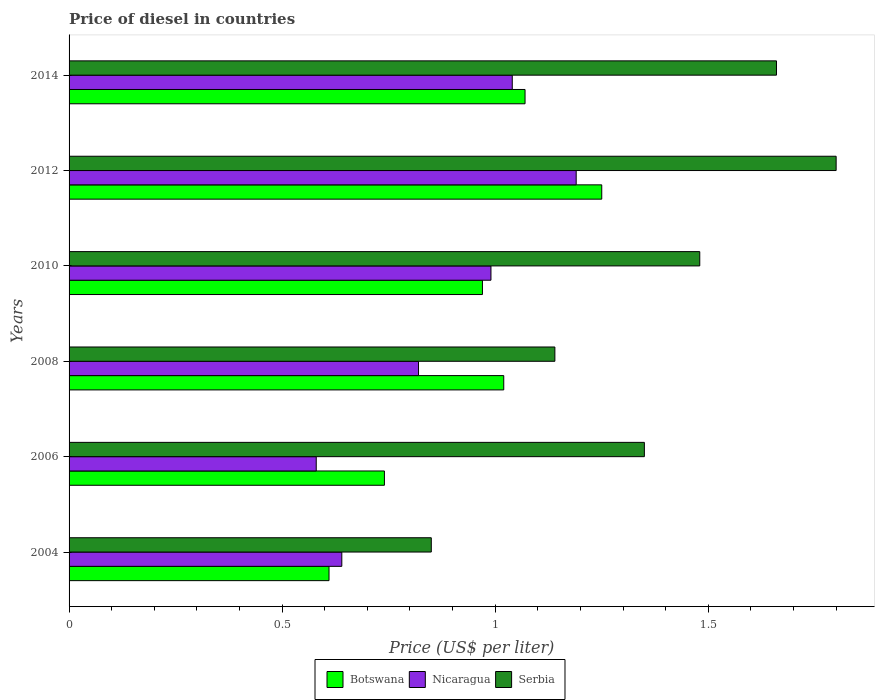How many different coloured bars are there?
Offer a very short reply. 3. How many groups of bars are there?
Offer a terse response. 6. Are the number of bars on each tick of the Y-axis equal?
Keep it short and to the point. Yes. In how many cases, is the number of bars for a given year not equal to the number of legend labels?
Keep it short and to the point. 0. Across all years, what is the maximum price of diesel in Botswana?
Your answer should be compact. 1.25. Across all years, what is the minimum price of diesel in Serbia?
Your response must be concise. 0.85. In which year was the price of diesel in Serbia minimum?
Offer a terse response. 2004. What is the total price of diesel in Serbia in the graph?
Your answer should be compact. 8.28. What is the difference between the price of diesel in Botswana in 2004 and that in 2010?
Your answer should be compact. -0.36. What is the difference between the price of diesel in Botswana in 2004 and the price of diesel in Nicaragua in 2010?
Offer a terse response. -0.38. What is the average price of diesel in Nicaragua per year?
Offer a terse response. 0.88. In the year 2006, what is the difference between the price of diesel in Serbia and price of diesel in Nicaragua?
Make the answer very short. 0.77. In how many years, is the price of diesel in Serbia greater than 0.6 US$?
Your answer should be very brief. 6. What is the ratio of the price of diesel in Nicaragua in 2004 to that in 2010?
Offer a very short reply. 0.65. Is the price of diesel in Nicaragua in 2004 less than that in 2012?
Offer a very short reply. Yes. What is the difference between the highest and the second highest price of diesel in Botswana?
Keep it short and to the point. 0.18. What is the difference between the highest and the lowest price of diesel in Nicaragua?
Keep it short and to the point. 0.61. Is the sum of the price of diesel in Serbia in 2004 and 2008 greater than the maximum price of diesel in Nicaragua across all years?
Offer a very short reply. Yes. What does the 2nd bar from the top in 2012 represents?
Provide a succinct answer. Nicaragua. What does the 1st bar from the bottom in 2012 represents?
Give a very brief answer. Botswana. How many years are there in the graph?
Your response must be concise. 6. Are the values on the major ticks of X-axis written in scientific E-notation?
Your answer should be very brief. No. Does the graph contain any zero values?
Provide a short and direct response. No. Does the graph contain grids?
Offer a terse response. No. What is the title of the graph?
Ensure brevity in your answer.  Price of diesel in countries. Does "Brunei Darussalam" appear as one of the legend labels in the graph?
Offer a very short reply. No. What is the label or title of the X-axis?
Your response must be concise. Price (US$ per liter). What is the Price (US$ per liter) in Botswana in 2004?
Offer a terse response. 0.61. What is the Price (US$ per liter) in Nicaragua in 2004?
Your answer should be very brief. 0.64. What is the Price (US$ per liter) in Serbia in 2004?
Make the answer very short. 0.85. What is the Price (US$ per liter) of Botswana in 2006?
Your answer should be very brief. 0.74. What is the Price (US$ per liter) in Nicaragua in 2006?
Provide a short and direct response. 0.58. What is the Price (US$ per liter) in Serbia in 2006?
Make the answer very short. 1.35. What is the Price (US$ per liter) in Botswana in 2008?
Make the answer very short. 1.02. What is the Price (US$ per liter) in Nicaragua in 2008?
Make the answer very short. 0.82. What is the Price (US$ per liter) in Serbia in 2008?
Offer a very short reply. 1.14. What is the Price (US$ per liter) in Nicaragua in 2010?
Your answer should be very brief. 0.99. What is the Price (US$ per liter) in Serbia in 2010?
Give a very brief answer. 1.48. What is the Price (US$ per liter) of Botswana in 2012?
Your response must be concise. 1.25. What is the Price (US$ per liter) in Nicaragua in 2012?
Keep it short and to the point. 1.19. What is the Price (US$ per liter) of Botswana in 2014?
Provide a short and direct response. 1.07. What is the Price (US$ per liter) in Serbia in 2014?
Offer a very short reply. 1.66. Across all years, what is the maximum Price (US$ per liter) in Nicaragua?
Your response must be concise. 1.19. Across all years, what is the maximum Price (US$ per liter) of Serbia?
Make the answer very short. 1.8. Across all years, what is the minimum Price (US$ per liter) in Botswana?
Your answer should be very brief. 0.61. Across all years, what is the minimum Price (US$ per liter) in Nicaragua?
Keep it short and to the point. 0.58. Across all years, what is the minimum Price (US$ per liter) in Serbia?
Offer a very short reply. 0.85. What is the total Price (US$ per liter) of Botswana in the graph?
Keep it short and to the point. 5.66. What is the total Price (US$ per liter) in Nicaragua in the graph?
Ensure brevity in your answer.  5.26. What is the total Price (US$ per liter) in Serbia in the graph?
Your response must be concise. 8.28. What is the difference between the Price (US$ per liter) of Botswana in 2004 and that in 2006?
Make the answer very short. -0.13. What is the difference between the Price (US$ per liter) in Nicaragua in 2004 and that in 2006?
Provide a succinct answer. 0.06. What is the difference between the Price (US$ per liter) of Serbia in 2004 and that in 2006?
Provide a short and direct response. -0.5. What is the difference between the Price (US$ per liter) of Botswana in 2004 and that in 2008?
Offer a terse response. -0.41. What is the difference between the Price (US$ per liter) of Nicaragua in 2004 and that in 2008?
Provide a short and direct response. -0.18. What is the difference between the Price (US$ per liter) in Serbia in 2004 and that in 2008?
Offer a terse response. -0.29. What is the difference between the Price (US$ per liter) of Botswana in 2004 and that in 2010?
Your answer should be compact. -0.36. What is the difference between the Price (US$ per liter) in Nicaragua in 2004 and that in 2010?
Your response must be concise. -0.35. What is the difference between the Price (US$ per liter) in Serbia in 2004 and that in 2010?
Provide a short and direct response. -0.63. What is the difference between the Price (US$ per liter) in Botswana in 2004 and that in 2012?
Ensure brevity in your answer.  -0.64. What is the difference between the Price (US$ per liter) in Nicaragua in 2004 and that in 2012?
Provide a short and direct response. -0.55. What is the difference between the Price (US$ per liter) of Serbia in 2004 and that in 2012?
Provide a succinct answer. -0.95. What is the difference between the Price (US$ per liter) in Botswana in 2004 and that in 2014?
Give a very brief answer. -0.46. What is the difference between the Price (US$ per liter) of Nicaragua in 2004 and that in 2014?
Your response must be concise. -0.4. What is the difference between the Price (US$ per liter) of Serbia in 2004 and that in 2014?
Your response must be concise. -0.81. What is the difference between the Price (US$ per liter) of Botswana in 2006 and that in 2008?
Give a very brief answer. -0.28. What is the difference between the Price (US$ per liter) of Nicaragua in 2006 and that in 2008?
Make the answer very short. -0.24. What is the difference between the Price (US$ per liter) of Serbia in 2006 and that in 2008?
Offer a terse response. 0.21. What is the difference between the Price (US$ per liter) in Botswana in 2006 and that in 2010?
Ensure brevity in your answer.  -0.23. What is the difference between the Price (US$ per liter) of Nicaragua in 2006 and that in 2010?
Ensure brevity in your answer.  -0.41. What is the difference between the Price (US$ per liter) of Serbia in 2006 and that in 2010?
Provide a short and direct response. -0.13. What is the difference between the Price (US$ per liter) of Botswana in 2006 and that in 2012?
Ensure brevity in your answer.  -0.51. What is the difference between the Price (US$ per liter) of Nicaragua in 2006 and that in 2012?
Offer a very short reply. -0.61. What is the difference between the Price (US$ per liter) of Serbia in 2006 and that in 2012?
Make the answer very short. -0.45. What is the difference between the Price (US$ per liter) in Botswana in 2006 and that in 2014?
Offer a very short reply. -0.33. What is the difference between the Price (US$ per liter) of Nicaragua in 2006 and that in 2014?
Your response must be concise. -0.46. What is the difference between the Price (US$ per liter) of Serbia in 2006 and that in 2014?
Keep it short and to the point. -0.31. What is the difference between the Price (US$ per liter) of Botswana in 2008 and that in 2010?
Give a very brief answer. 0.05. What is the difference between the Price (US$ per liter) of Nicaragua in 2008 and that in 2010?
Your response must be concise. -0.17. What is the difference between the Price (US$ per liter) of Serbia in 2008 and that in 2010?
Ensure brevity in your answer.  -0.34. What is the difference between the Price (US$ per liter) of Botswana in 2008 and that in 2012?
Your answer should be very brief. -0.23. What is the difference between the Price (US$ per liter) in Nicaragua in 2008 and that in 2012?
Provide a succinct answer. -0.37. What is the difference between the Price (US$ per liter) of Serbia in 2008 and that in 2012?
Your response must be concise. -0.66. What is the difference between the Price (US$ per liter) in Nicaragua in 2008 and that in 2014?
Offer a very short reply. -0.22. What is the difference between the Price (US$ per liter) in Serbia in 2008 and that in 2014?
Make the answer very short. -0.52. What is the difference between the Price (US$ per liter) of Botswana in 2010 and that in 2012?
Make the answer very short. -0.28. What is the difference between the Price (US$ per liter) of Nicaragua in 2010 and that in 2012?
Ensure brevity in your answer.  -0.2. What is the difference between the Price (US$ per liter) of Serbia in 2010 and that in 2012?
Your response must be concise. -0.32. What is the difference between the Price (US$ per liter) in Serbia in 2010 and that in 2014?
Provide a succinct answer. -0.18. What is the difference between the Price (US$ per liter) in Botswana in 2012 and that in 2014?
Provide a short and direct response. 0.18. What is the difference between the Price (US$ per liter) in Serbia in 2012 and that in 2014?
Provide a succinct answer. 0.14. What is the difference between the Price (US$ per liter) in Botswana in 2004 and the Price (US$ per liter) in Nicaragua in 2006?
Keep it short and to the point. 0.03. What is the difference between the Price (US$ per liter) of Botswana in 2004 and the Price (US$ per liter) of Serbia in 2006?
Give a very brief answer. -0.74. What is the difference between the Price (US$ per liter) in Nicaragua in 2004 and the Price (US$ per liter) in Serbia in 2006?
Your answer should be compact. -0.71. What is the difference between the Price (US$ per liter) of Botswana in 2004 and the Price (US$ per liter) of Nicaragua in 2008?
Provide a short and direct response. -0.21. What is the difference between the Price (US$ per liter) in Botswana in 2004 and the Price (US$ per liter) in Serbia in 2008?
Offer a very short reply. -0.53. What is the difference between the Price (US$ per liter) of Nicaragua in 2004 and the Price (US$ per liter) of Serbia in 2008?
Your answer should be very brief. -0.5. What is the difference between the Price (US$ per liter) in Botswana in 2004 and the Price (US$ per liter) in Nicaragua in 2010?
Ensure brevity in your answer.  -0.38. What is the difference between the Price (US$ per liter) of Botswana in 2004 and the Price (US$ per liter) of Serbia in 2010?
Your answer should be compact. -0.87. What is the difference between the Price (US$ per liter) of Nicaragua in 2004 and the Price (US$ per liter) of Serbia in 2010?
Provide a short and direct response. -0.84. What is the difference between the Price (US$ per liter) in Botswana in 2004 and the Price (US$ per liter) in Nicaragua in 2012?
Your answer should be compact. -0.58. What is the difference between the Price (US$ per liter) in Botswana in 2004 and the Price (US$ per liter) in Serbia in 2012?
Provide a succinct answer. -1.19. What is the difference between the Price (US$ per liter) in Nicaragua in 2004 and the Price (US$ per liter) in Serbia in 2012?
Offer a terse response. -1.16. What is the difference between the Price (US$ per liter) in Botswana in 2004 and the Price (US$ per liter) in Nicaragua in 2014?
Offer a terse response. -0.43. What is the difference between the Price (US$ per liter) of Botswana in 2004 and the Price (US$ per liter) of Serbia in 2014?
Your answer should be compact. -1.05. What is the difference between the Price (US$ per liter) in Nicaragua in 2004 and the Price (US$ per liter) in Serbia in 2014?
Your answer should be very brief. -1.02. What is the difference between the Price (US$ per liter) of Botswana in 2006 and the Price (US$ per liter) of Nicaragua in 2008?
Offer a very short reply. -0.08. What is the difference between the Price (US$ per liter) in Botswana in 2006 and the Price (US$ per liter) in Serbia in 2008?
Your answer should be very brief. -0.4. What is the difference between the Price (US$ per liter) of Nicaragua in 2006 and the Price (US$ per liter) of Serbia in 2008?
Provide a short and direct response. -0.56. What is the difference between the Price (US$ per liter) in Botswana in 2006 and the Price (US$ per liter) in Nicaragua in 2010?
Your answer should be very brief. -0.25. What is the difference between the Price (US$ per liter) of Botswana in 2006 and the Price (US$ per liter) of Serbia in 2010?
Offer a very short reply. -0.74. What is the difference between the Price (US$ per liter) in Botswana in 2006 and the Price (US$ per liter) in Nicaragua in 2012?
Your response must be concise. -0.45. What is the difference between the Price (US$ per liter) of Botswana in 2006 and the Price (US$ per liter) of Serbia in 2012?
Your response must be concise. -1.06. What is the difference between the Price (US$ per liter) of Nicaragua in 2006 and the Price (US$ per liter) of Serbia in 2012?
Your response must be concise. -1.22. What is the difference between the Price (US$ per liter) of Botswana in 2006 and the Price (US$ per liter) of Nicaragua in 2014?
Offer a terse response. -0.3. What is the difference between the Price (US$ per liter) of Botswana in 2006 and the Price (US$ per liter) of Serbia in 2014?
Ensure brevity in your answer.  -0.92. What is the difference between the Price (US$ per liter) in Nicaragua in 2006 and the Price (US$ per liter) in Serbia in 2014?
Provide a succinct answer. -1.08. What is the difference between the Price (US$ per liter) in Botswana in 2008 and the Price (US$ per liter) in Serbia in 2010?
Make the answer very short. -0.46. What is the difference between the Price (US$ per liter) in Nicaragua in 2008 and the Price (US$ per liter) in Serbia in 2010?
Your response must be concise. -0.66. What is the difference between the Price (US$ per liter) in Botswana in 2008 and the Price (US$ per liter) in Nicaragua in 2012?
Your answer should be very brief. -0.17. What is the difference between the Price (US$ per liter) of Botswana in 2008 and the Price (US$ per liter) of Serbia in 2012?
Provide a succinct answer. -0.78. What is the difference between the Price (US$ per liter) of Nicaragua in 2008 and the Price (US$ per liter) of Serbia in 2012?
Your response must be concise. -0.98. What is the difference between the Price (US$ per liter) of Botswana in 2008 and the Price (US$ per liter) of Nicaragua in 2014?
Keep it short and to the point. -0.02. What is the difference between the Price (US$ per liter) in Botswana in 2008 and the Price (US$ per liter) in Serbia in 2014?
Keep it short and to the point. -0.64. What is the difference between the Price (US$ per liter) in Nicaragua in 2008 and the Price (US$ per liter) in Serbia in 2014?
Offer a very short reply. -0.84. What is the difference between the Price (US$ per liter) of Botswana in 2010 and the Price (US$ per liter) of Nicaragua in 2012?
Offer a very short reply. -0.22. What is the difference between the Price (US$ per liter) of Botswana in 2010 and the Price (US$ per liter) of Serbia in 2012?
Ensure brevity in your answer.  -0.83. What is the difference between the Price (US$ per liter) of Nicaragua in 2010 and the Price (US$ per liter) of Serbia in 2012?
Keep it short and to the point. -0.81. What is the difference between the Price (US$ per liter) of Botswana in 2010 and the Price (US$ per liter) of Nicaragua in 2014?
Make the answer very short. -0.07. What is the difference between the Price (US$ per liter) in Botswana in 2010 and the Price (US$ per liter) in Serbia in 2014?
Provide a short and direct response. -0.69. What is the difference between the Price (US$ per liter) in Nicaragua in 2010 and the Price (US$ per liter) in Serbia in 2014?
Offer a very short reply. -0.67. What is the difference between the Price (US$ per liter) of Botswana in 2012 and the Price (US$ per liter) of Nicaragua in 2014?
Make the answer very short. 0.21. What is the difference between the Price (US$ per liter) in Botswana in 2012 and the Price (US$ per liter) in Serbia in 2014?
Make the answer very short. -0.41. What is the difference between the Price (US$ per liter) of Nicaragua in 2012 and the Price (US$ per liter) of Serbia in 2014?
Provide a succinct answer. -0.47. What is the average Price (US$ per liter) of Botswana per year?
Your answer should be very brief. 0.94. What is the average Price (US$ per liter) of Nicaragua per year?
Keep it short and to the point. 0.88. What is the average Price (US$ per liter) in Serbia per year?
Make the answer very short. 1.38. In the year 2004, what is the difference between the Price (US$ per liter) of Botswana and Price (US$ per liter) of Nicaragua?
Your answer should be very brief. -0.03. In the year 2004, what is the difference between the Price (US$ per liter) of Botswana and Price (US$ per liter) of Serbia?
Give a very brief answer. -0.24. In the year 2004, what is the difference between the Price (US$ per liter) in Nicaragua and Price (US$ per liter) in Serbia?
Offer a very short reply. -0.21. In the year 2006, what is the difference between the Price (US$ per liter) in Botswana and Price (US$ per liter) in Nicaragua?
Provide a short and direct response. 0.16. In the year 2006, what is the difference between the Price (US$ per liter) of Botswana and Price (US$ per liter) of Serbia?
Provide a short and direct response. -0.61. In the year 2006, what is the difference between the Price (US$ per liter) in Nicaragua and Price (US$ per liter) in Serbia?
Offer a very short reply. -0.77. In the year 2008, what is the difference between the Price (US$ per liter) in Botswana and Price (US$ per liter) in Nicaragua?
Your response must be concise. 0.2. In the year 2008, what is the difference between the Price (US$ per liter) of Botswana and Price (US$ per liter) of Serbia?
Ensure brevity in your answer.  -0.12. In the year 2008, what is the difference between the Price (US$ per liter) of Nicaragua and Price (US$ per liter) of Serbia?
Offer a terse response. -0.32. In the year 2010, what is the difference between the Price (US$ per liter) in Botswana and Price (US$ per liter) in Nicaragua?
Ensure brevity in your answer.  -0.02. In the year 2010, what is the difference between the Price (US$ per liter) of Botswana and Price (US$ per liter) of Serbia?
Give a very brief answer. -0.51. In the year 2010, what is the difference between the Price (US$ per liter) in Nicaragua and Price (US$ per liter) in Serbia?
Provide a short and direct response. -0.49. In the year 2012, what is the difference between the Price (US$ per liter) in Botswana and Price (US$ per liter) in Serbia?
Offer a terse response. -0.55. In the year 2012, what is the difference between the Price (US$ per liter) of Nicaragua and Price (US$ per liter) of Serbia?
Offer a terse response. -0.61. In the year 2014, what is the difference between the Price (US$ per liter) of Botswana and Price (US$ per liter) of Serbia?
Keep it short and to the point. -0.59. In the year 2014, what is the difference between the Price (US$ per liter) of Nicaragua and Price (US$ per liter) of Serbia?
Offer a very short reply. -0.62. What is the ratio of the Price (US$ per liter) of Botswana in 2004 to that in 2006?
Make the answer very short. 0.82. What is the ratio of the Price (US$ per liter) of Nicaragua in 2004 to that in 2006?
Your answer should be very brief. 1.1. What is the ratio of the Price (US$ per liter) of Serbia in 2004 to that in 2006?
Provide a succinct answer. 0.63. What is the ratio of the Price (US$ per liter) of Botswana in 2004 to that in 2008?
Ensure brevity in your answer.  0.6. What is the ratio of the Price (US$ per liter) of Nicaragua in 2004 to that in 2008?
Provide a succinct answer. 0.78. What is the ratio of the Price (US$ per liter) in Serbia in 2004 to that in 2008?
Offer a terse response. 0.75. What is the ratio of the Price (US$ per liter) of Botswana in 2004 to that in 2010?
Your answer should be compact. 0.63. What is the ratio of the Price (US$ per liter) of Nicaragua in 2004 to that in 2010?
Make the answer very short. 0.65. What is the ratio of the Price (US$ per liter) in Serbia in 2004 to that in 2010?
Offer a terse response. 0.57. What is the ratio of the Price (US$ per liter) of Botswana in 2004 to that in 2012?
Keep it short and to the point. 0.49. What is the ratio of the Price (US$ per liter) in Nicaragua in 2004 to that in 2012?
Make the answer very short. 0.54. What is the ratio of the Price (US$ per liter) of Serbia in 2004 to that in 2012?
Your response must be concise. 0.47. What is the ratio of the Price (US$ per liter) of Botswana in 2004 to that in 2014?
Ensure brevity in your answer.  0.57. What is the ratio of the Price (US$ per liter) in Nicaragua in 2004 to that in 2014?
Give a very brief answer. 0.62. What is the ratio of the Price (US$ per liter) in Serbia in 2004 to that in 2014?
Your answer should be very brief. 0.51. What is the ratio of the Price (US$ per liter) of Botswana in 2006 to that in 2008?
Provide a succinct answer. 0.73. What is the ratio of the Price (US$ per liter) of Nicaragua in 2006 to that in 2008?
Make the answer very short. 0.71. What is the ratio of the Price (US$ per liter) of Serbia in 2006 to that in 2008?
Offer a terse response. 1.18. What is the ratio of the Price (US$ per liter) of Botswana in 2006 to that in 2010?
Provide a short and direct response. 0.76. What is the ratio of the Price (US$ per liter) of Nicaragua in 2006 to that in 2010?
Provide a short and direct response. 0.59. What is the ratio of the Price (US$ per liter) of Serbia in 2006 to that in 2010?
Your answer should be very brief. 0.91. What is the ratio of the Price (US$ per liter) of Botswana in 2006 to that in 2012?
Your answer should be very brief. 0.59. What is the ratio of the Price (US$ per liter) in Nicaragua in 2006 to that in 2012?
Offer a very short reply. 0.49. What is the ratio of the Price (US$ per liter) in Botswana in 2006 to that in 2014?
Keep it short and to the point. 0.69. What is the ratio of the Price (US$ per liter) of Nicaragua in 2006 to that in 2014?
Make the answer very short. 0.56. What is the ratio of the Price (US$ per liter) of Serbia in 2006 to that in 2014?
Offer a very short reply. 0.81. What is the ratio of the Price (US$ per liter) of Botswana in 2008 to that in 2010?
Provide a short and direct response. 1.05. What is the ratio of the Price (US$ per liter) of Nicaragua in 2008 to that in 2010?
Your answer should be compact. 0.83. What is the ratio of the Price (US$ per liter) of Serbia in 2008 to that in 2010?
Give a very brief answer. 0.77. What is the ratio of the Price (US$ per liter) of Botswana in 2008 to that in 2012?
Your answer should be compact. 0.82. What is the ratio of the Price (US$ per liter) in Nicaragua in 2008 to that in 2012?
Make the answer very short. 0.69. What is the ratio of the Price (US$ per liter) of Serbia in 2008 to that in 2012?
Your response must be concise. 0.63. What is the ratio of the Price (US$ per liter) in Botswana in 2008 to that in 2014?
Ensure brevity in your answer.  0.95. What is the ratio of the Price (US$ per liter) in Nicaragua in 2008 to that in 2014?
Provide a short and direct response. 0.79. What is the ratio of the Price (US$ per liter) of Serbia in 2008 to that in 2014?
Your answer should be very brief. 0.69. What is the ratio of the Price (US$ per liter) in Botswana in 2010 to that in 2012?
Your response must be concise. 0.78. What is the ratio of the Price (US$ per liter) of Nicaragua in 2010 to that in 2012?
Offer a very short reply. 0.83. What is the ratio of the Price (US$ per liter) in Serbia in 2010 to that in 2012?
Provide a succinct answer. 0.82. What is the ratio of the Price (US$ per liter) of Botswana in 2010 to that in 2014?
Give a very brief answer. 0.91. What is the ratio of the Price (US$ per liter) in Nicaragua in 2010 to that in 2014?
Provide a succinct answer. 0.95. What is the ratio of the Price (US$ per liter) of Serbia in 2010 to that in 2014?
Offer a very short reply. 0.89. What is the ratio of the Price (US$ per liter) in Botswana in 2012 to that in 2014?
Your answer should be compact. 1.17. What is the ratio of the Price (US$ per liter) of Nicaragua in 2012 to that in 2014?
Provide a short and direct response. 1.14. What is the ratio of the Price (US$ per liter) in Serbia in 2012 to that in 2014?
Ensure brevity in your answer.  1.08. What is the difference between the highest and the second highest Price (US$ per liter) of Botswana?
Provide a succinct answer. 0.18. What is the difference between the highest and the second highest Price (US$ per liter) of Nicaragua?
Offer a very short reply. 0.15. What is the difference between the highest and the second highest Price (US$ per liter) in Serbia?
Your answer should be compact. 0.14. What is the difference between the highest and the lowest Price (US$ per liter) in Botswana?
Give a very brief answer. 0.64. What is the difference between the highest and the lowest Price (US$ per liter) in Nicaragua?
Your answer should be compact. 0.61. 